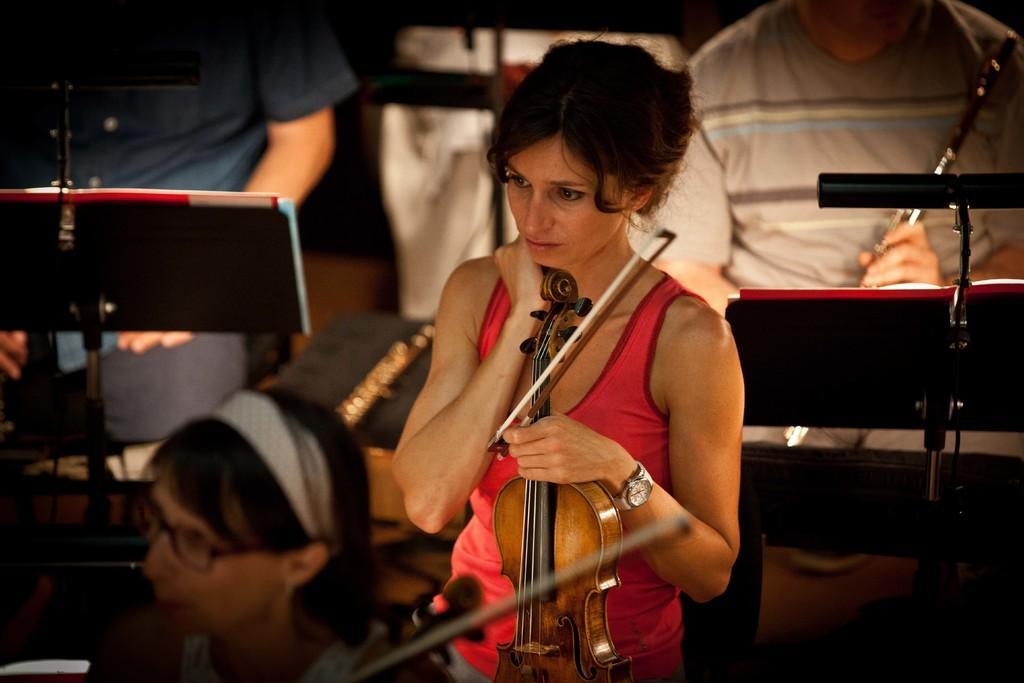Can you describe this image briefly? In this image we can see a woman holding a musical instrument and standing and we can also see some other persons holding musical instruments. 